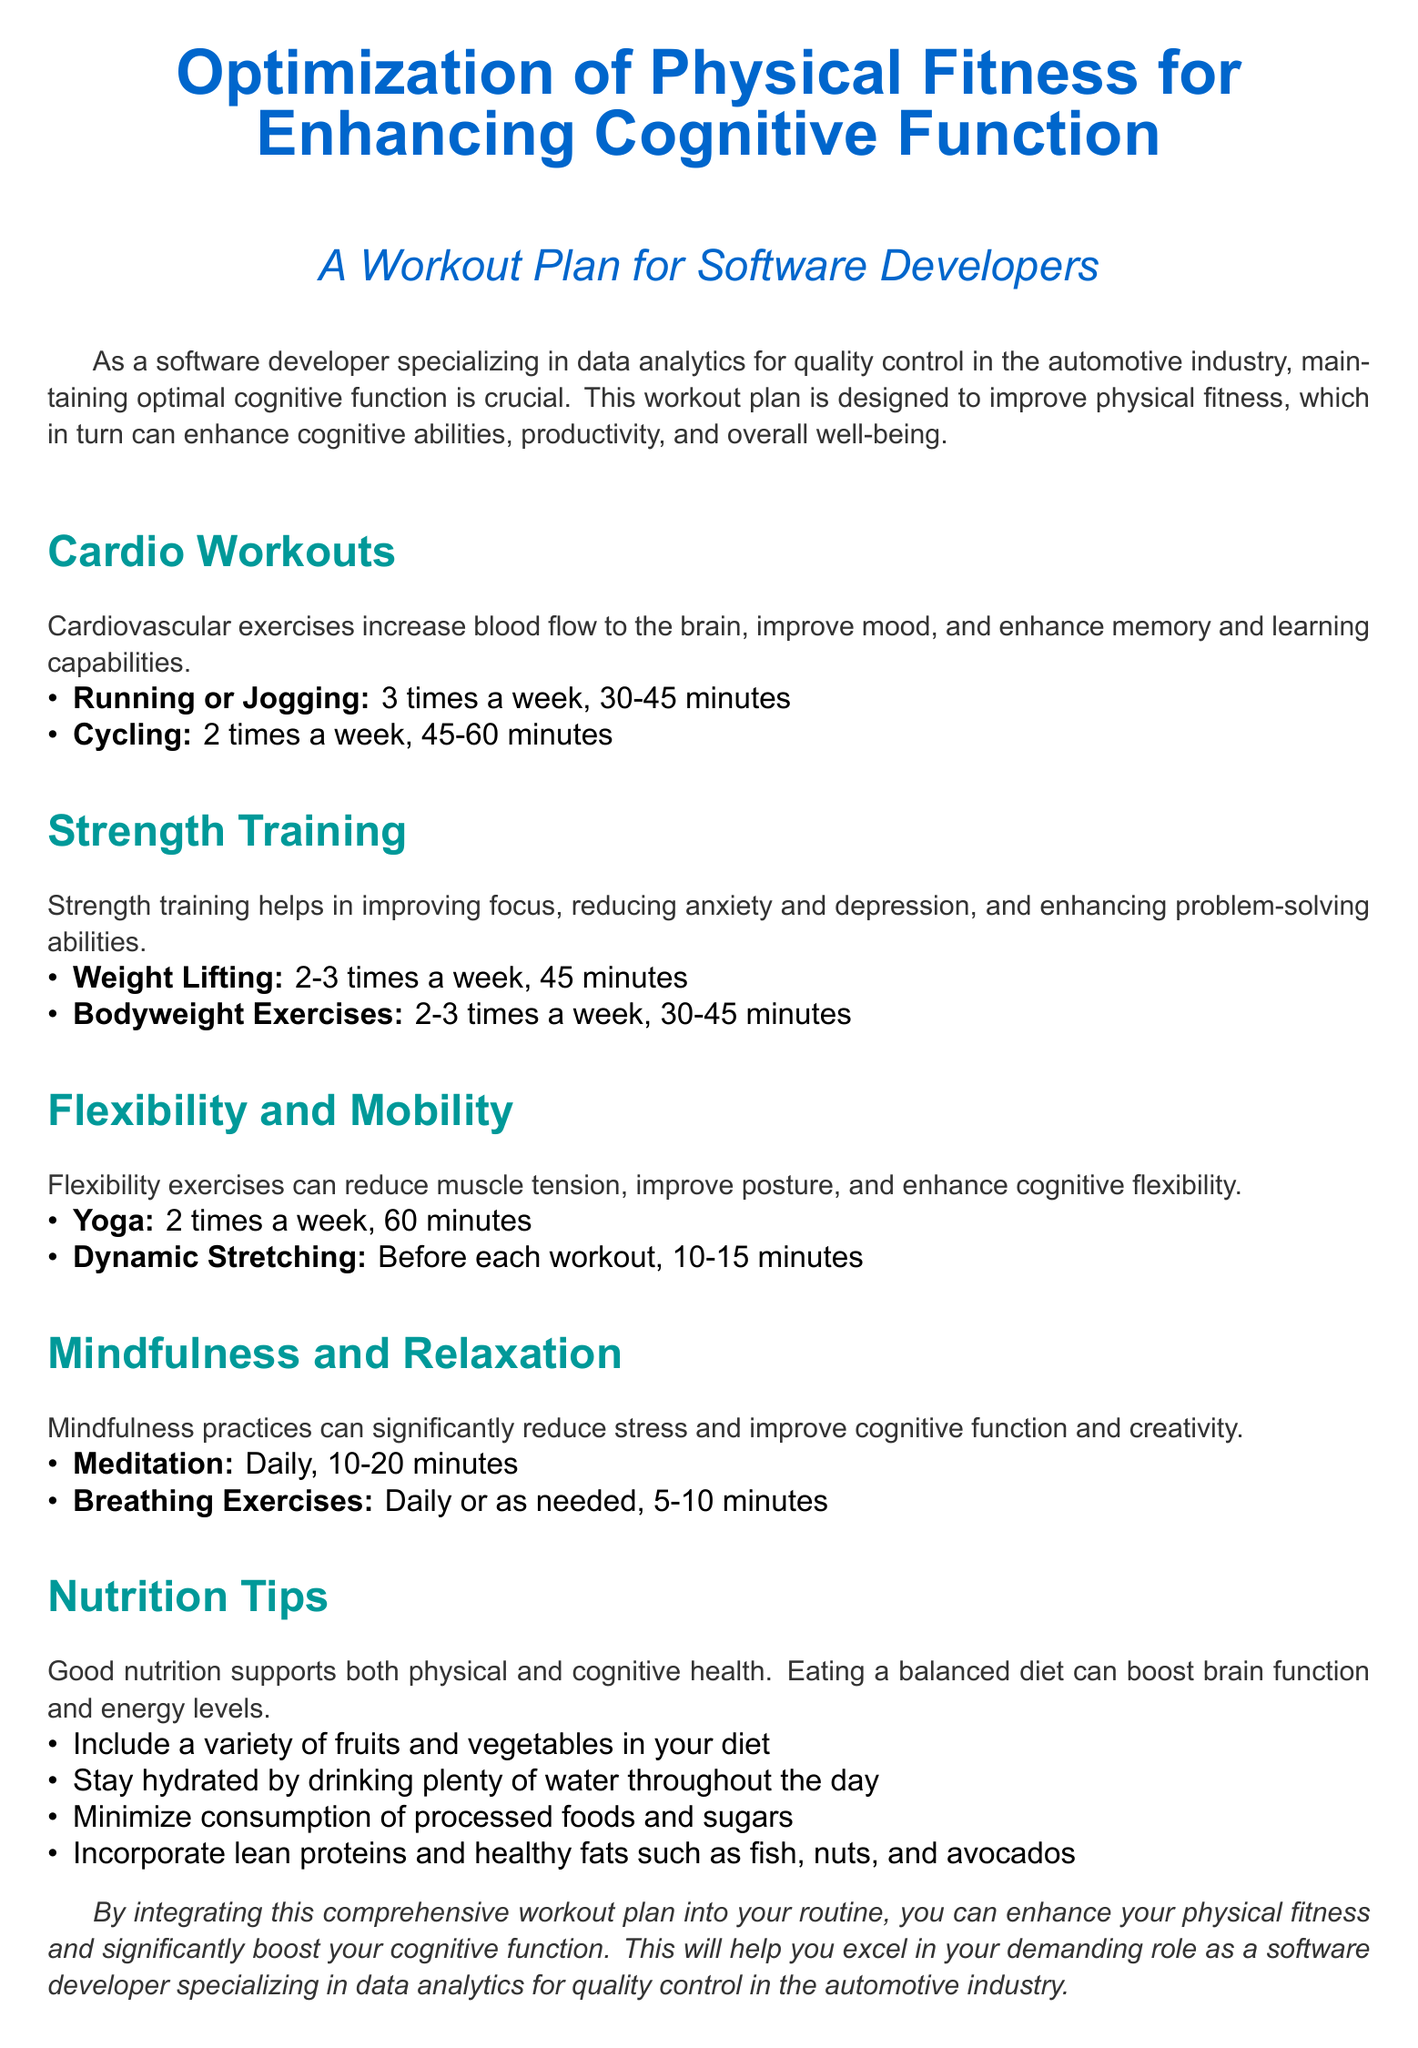what is the main focus of the document? The focus of the document is on optimizing physical fitness to enhance cognitive function for software developers.
Answer: optimizing physical fitness how many times a week should you do yoga? The document states that yoga should be done 2 times a week.
Answer: 2 times what is the recommended duration for running or jogging? The document recommends running or jogging for 30-45 minutes.
Answer: 30-45 minutes what type of exercises can enhance problem-solving abilities? Strength training exercises are noted to help enhance problem-solving abilities.
Answer: Strength training what is advised before each workout? The document advises doing dynamic stretching before each workout.
Answer: dynamic stretching how often should meditation be practiced? Meditation should be practiced daily as per the document.
Answer: Daily which nutrient sources are recommended for a balanced diet? The document recommends lean proteins and healthy fats such as fish, nuts, and avocados.
Answer: lean proteins and healthy fats what is the purpose of mindfulness practices in the plan? Mindfulness practices aim to reduce stress and improve cognitive function and creativity.
Answer: reduce stress and improve cognitive function how long should breathing exercises last? Breathing exercises should last 5-10 minutes according to the document.
Answer: 5-10 minutes 